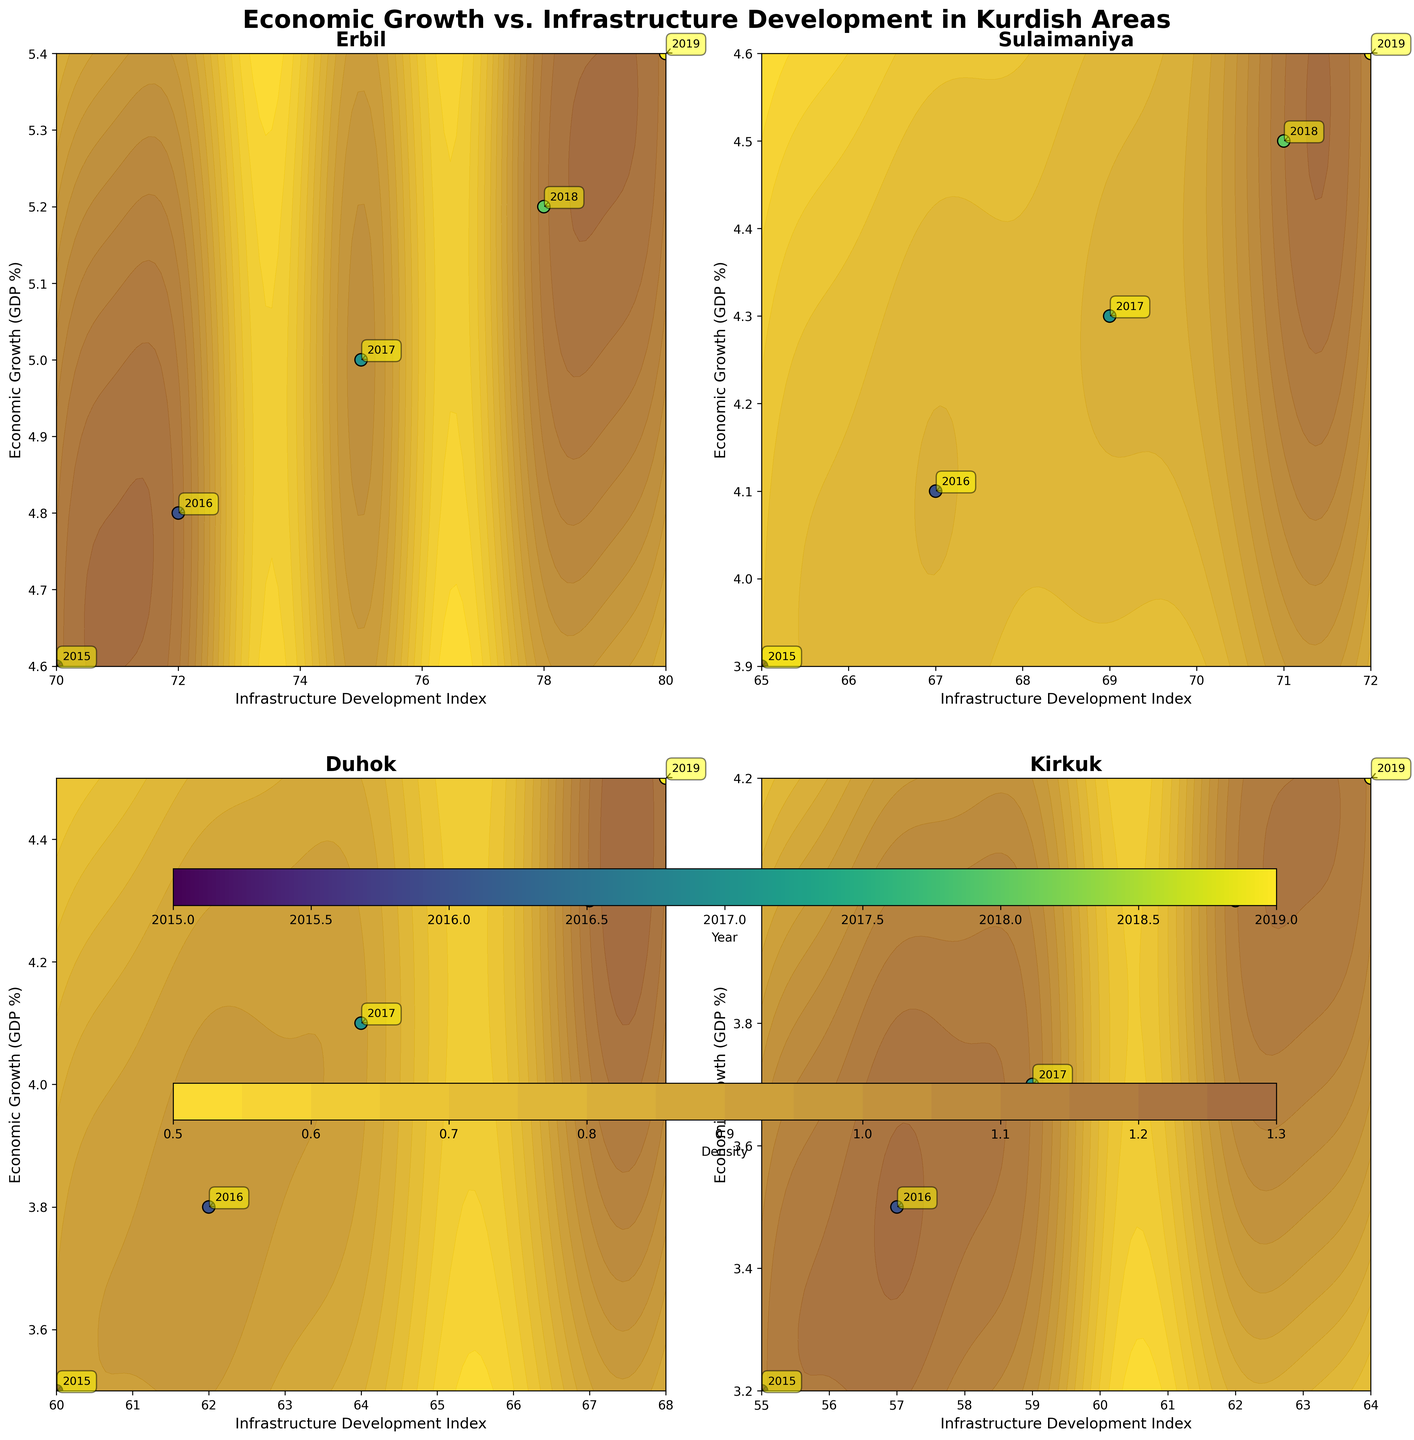What is the title of the figure? The title of the figure is usually displayed at the top of the chart. Here, it is "Economic Growth vs. Infrastructure Development in Kurdish Areas" as stated in the `suptitle`.
Answer: Economic Growth vs. Infrastructure Development in Kurdish Areas Which region shows the highest economic growth in 2019? By looking at the scatter plots for each region and identifying the point labeled as "2019", you can compare the 'Economic Growth (GDP %)' value. The scatter plot for Erbil shows the highest economic growth at 5.4%.
Answer: Erbil How does the Economic Growth in Sulaimaniya compare to Duhok in 2018? Locate the points labeled "2018" on both the Sulaimaniya and Duhok subplots. Sulaimaniya's 2018 point has an economic growth of 4.5%, while Duhok's 2018 point shows 4.3%.
Answer: Sulaimaniya's economic growth is higher Which region has the highest infrastructure development index in 2016? For each region, find the point labeled "2016" and look at the 'Infrastructure Development Index' value. Erbil's point for 2016 has the highest value at 72.
Answer: Erbil Which region shows a consistent upward trend in both economic growth and infrastructure development from 2015 to 2019? By examining each subplot, look for regions where both economic growth (y-axis) and infrastructure development (x-axis) increase consistently over the years. Erbil shows this trend with values increasing steadily.
Answer: Erbil What color represents the year 2017 in the scatter plots? The scatter plots use the 'viridis' colormap to represent years, as stated in the code. Observing the color gradient and identifying the color for the year 2017, it is typically a greenish shade.
Answer: Greenish shade How does the economic growth in Kirkuk change from 2015 to 2019? Trace the points labeled from "2015" to "2019" on the Kirkuk subplot. The economic growth increases from 3.2% in 2015 to 4.2% in 2019.
Answer: It increased Identify the contour level that appears the most dense in Duhok. Examine the contour levels on the Duhok subplot. The density can be inferred from the color shading, with darker shades indicating higher density. Usually, the center-most contours are the densest.
Answer: Center-most contour levels What is the range of the infrastructure development index in Kirkuk from 2015 to 2019? Check the x-axis values for the points labeled from "2015" to "2019" on the Kirkuk subplot. The index ranges from 55 in 2015 to 64 in 2019.
Answer: 55 to 64 